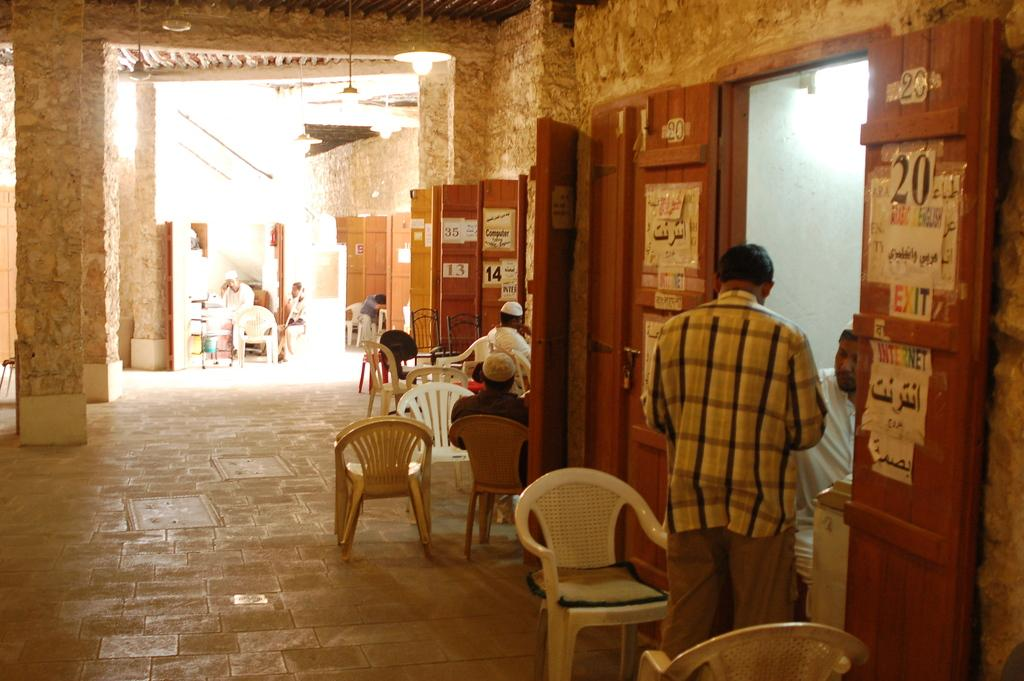Where is the person located in the image? The person is standing in the right corner of the image. What is the setting of the image? The person is outside a store. Are there any other stores nearby? Yes, there are other stores beside the store the person is standing near. What type of art can be seen on the walls of the store in the image? There is no art visible on the walls of the store in the image. Has a crime been committed in the image? There is no indication of a crime being committed in the image. 